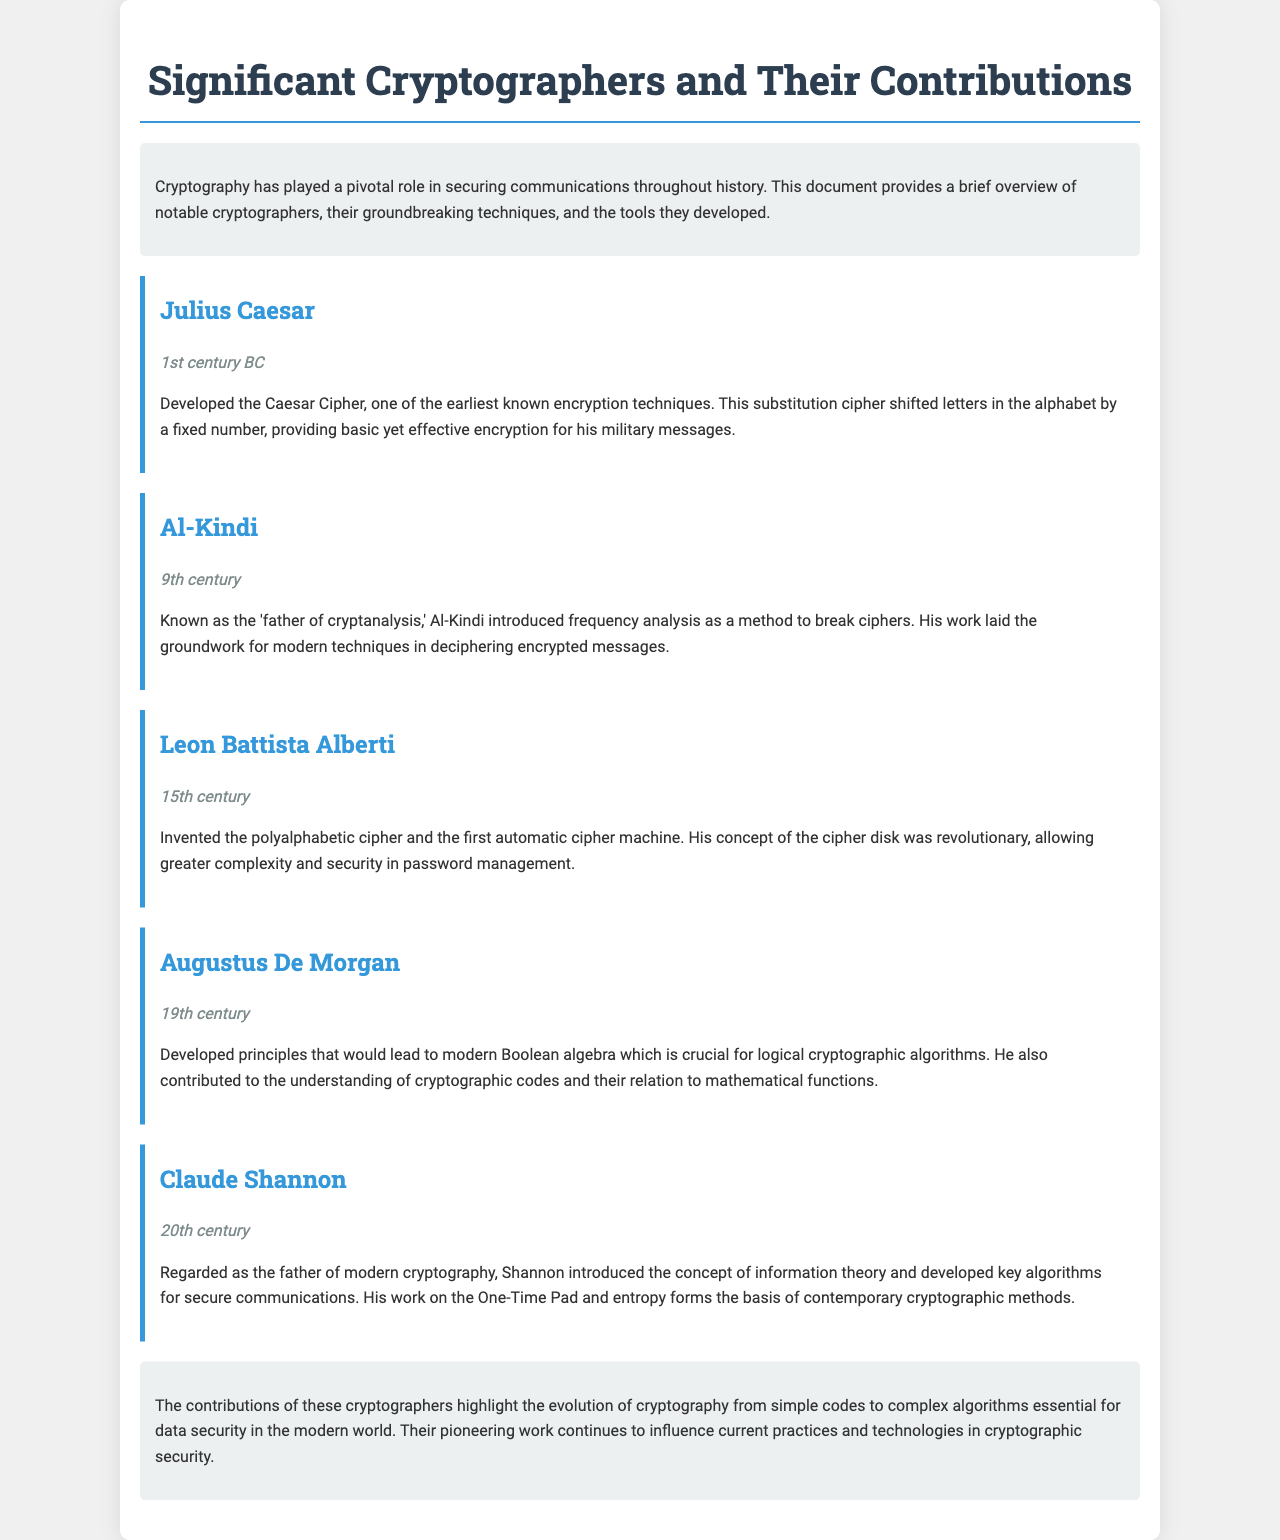What encryption technique did Julius Caesar develop? The document states that Julius Caesar developed the Caesar Cipher, a substitution cipher.
Answer: Caesar Cipher Who is known as the "father of cryptanalysis"? According to the document, Al-Kindi is referred to as the "father of cryptanalysis."
Answer: Al-Kindi In which century did Claude Shannon contribute to cryptography? The document indicates that Claude Shannon's contributions occurred in the 20th century.
Answer: 20th century What significant concept did Shannon introduce in cryptography? The document mentions that Shannon introduced the concept of information theory.
Answer: Information theory What invention is Leon Battista Alberti known for? The document states that Alberti invented the polyalphabetic cipher and the first automatic cipher machine.
Answer: Polyalphabetic cipher Which cryptographer's work laid the groundwork for modern deciphering techniques? The document notes that Al-Kindi's work laid the groundwork for modern techniques in deciphering encrypted messages.
Answer: Al-Kindi What is the primary focus of Augustus De Morgan's contributions? According to the document, De Morgan developed principles leading to modern Boolean algebra which is crucial for logical cryptographic algorithms.
Answer: Boolean algebra What does the conclusion emphasize about the contributions of these cryptographers? The document's conclusion highlights the evolution of cryptography from simple codes to complex algorithms essential for data security.
Answer: Evolution of cryptography 